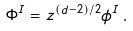Convert formula to latex. <formula><loc_0><loc_0><loc_500><loc_500>\Phi ^ { I } = z ^ { ( d - 2 ) / 2 } \phi ^ { I } \, .</formula> 